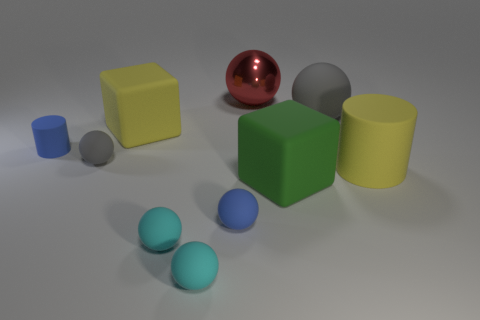The large rubber thing that is in front of the large matte cylinder has what shape?
Provide a succinct answer. Cube. How many objects are large yellow rubber cubes or large rubber spheres?
Give a very brief answer. 2. Does the red shiny thing have the same size as the gray object on the left side of the small blue rubber ball?
Provide a short and direct response. No. What number of other things are there of the same material as the small gray object
Your answer should be compact. 8. What number of things are rubber cylinders that are left of the yellow block or small blue matte objects that are in front of the green block?
Ensure brevity in your answer.  2. There is a small blue object that is the same shape as the red object; what is it made of?
Give a very brief answer. Rubber. Are there any large matte cylinders?
Provide a short and direct response. Yes. There is a rubber thing that is both left of the large green cube and behind the small rubber cylinder; what is its size?
Make the answer very short. Large. There is a red object; what shape is it?
Keep it short and to the point. Sphere. Are there any small blue cylinders that are behind the large yellow matte object that is on the left side of the big green matte cube?
Your answer should be compact. No. 